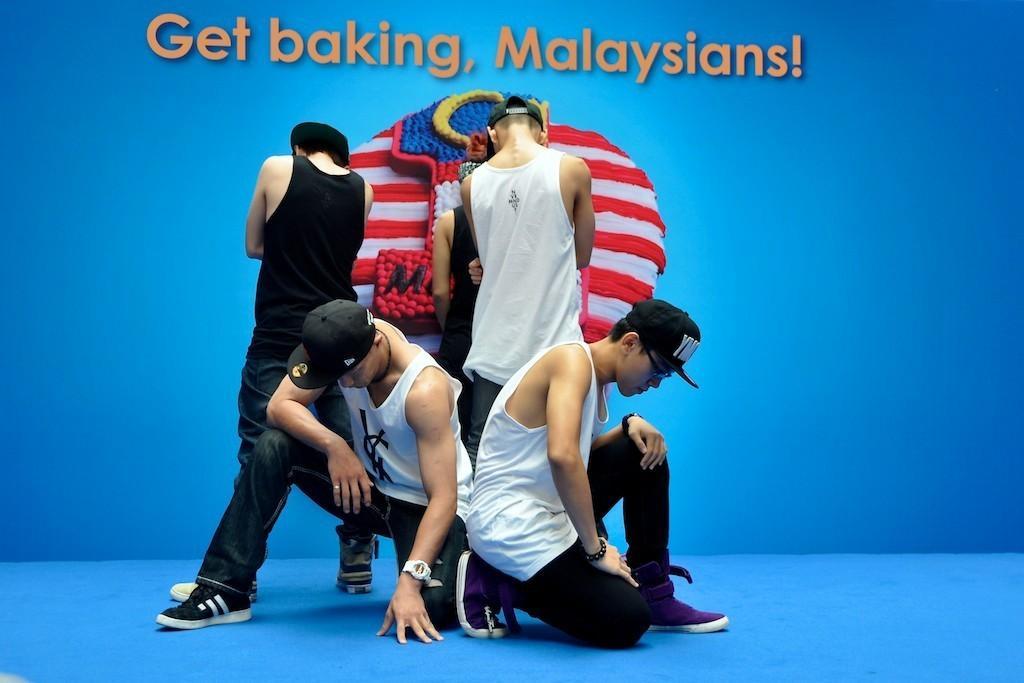Please provide a concise description of this image. In this image I can see the group of people with white and black color dresses and I can see these people with caps. In the background I can see an object and there is something is written. I can see the blue color background. 